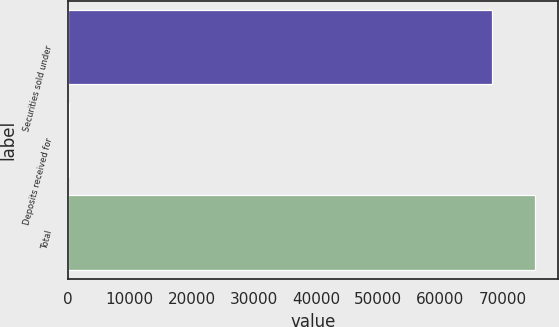Convert chart. <chart><loc_0><loc_0><loc_500><loc_500><bar_chart><fcel>Securities sold under<fcel>Deposits received for<fcel>Total<nl><fcel>68372<fcel>266<fcel>75209.2<nl></chart> 